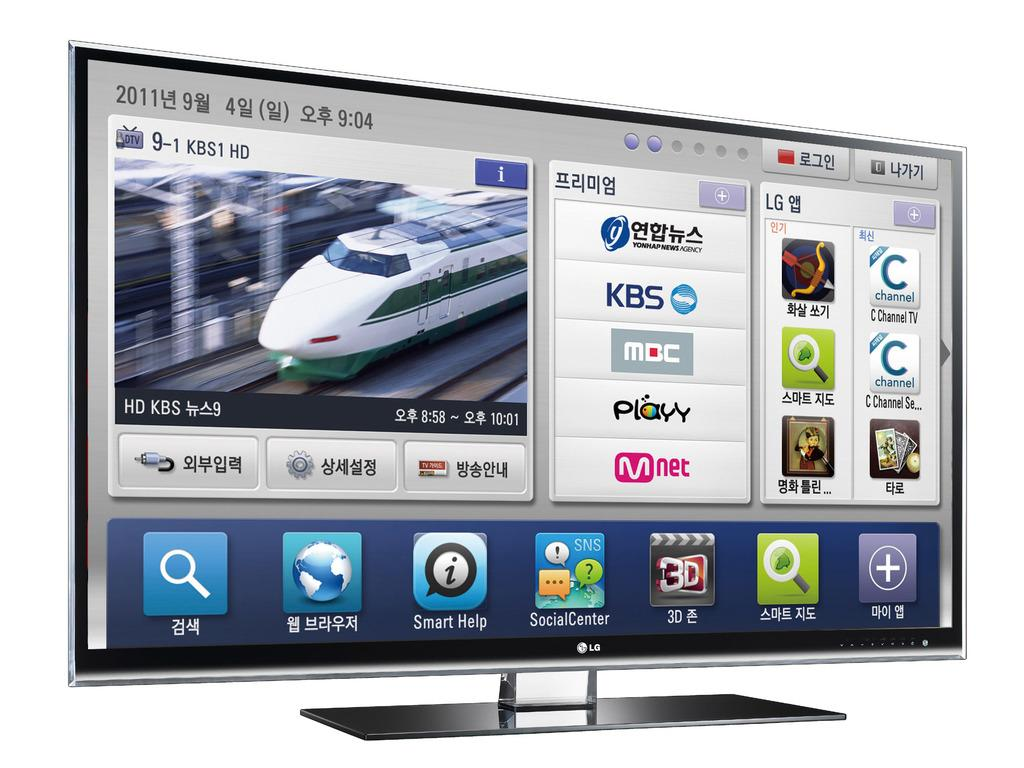<image>
Summarize the visual content of the image. A monitor shows 2011 in the upper left corner and the time of 9:04. 